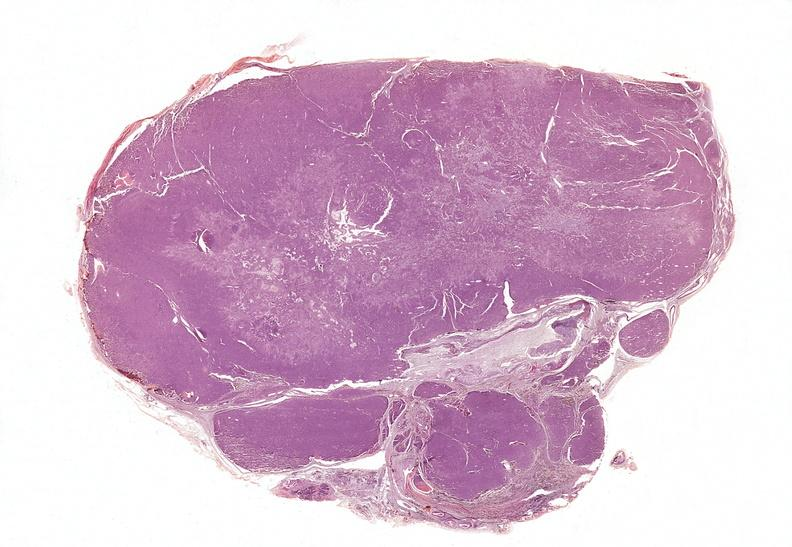what does this image show?
Answer the question using a single word or phrase. Parathyroid 